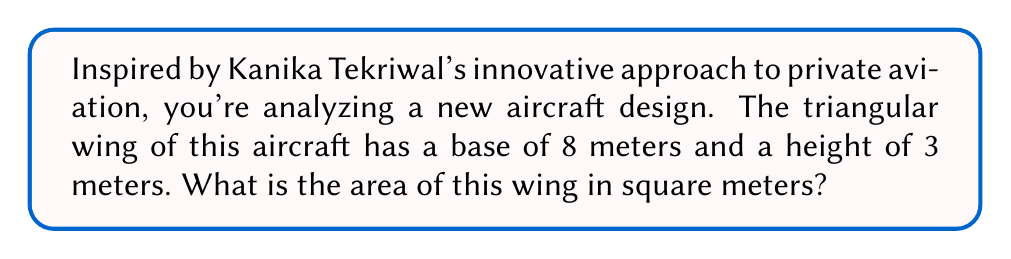Show me your answer to this math problem. To find the area of a triangular wing, we can use the formula for the area of a triangle:

$$A = \frac{1}{2} \times b \times h$$

Where:
$A$ = Area of the triangle
$b$ = Base of the triangle
$h$ = Height (perpendicular to the base) of the triangle

Given:
Base $(b) = 8$ meters
Height $(h) = 3$ meters

Let's substitute these values into the formula:

$$A = \frac{1}{2} \times 8 \times 3$$

Simplifying:
$$A = 4 \times 3 = 12$$

Therefore, the area of the triangular aircraft wing is 12 square meters.

[asy]
import geometry;

size(200);
pair A = (0,0), B = (8,0), C = (4,3);
draw(A--B--C--cycle);
draw(C--(4,0), dashed);
label("8 m", (4,0), S);
label("3 m", (4,1.5), E);
label("A = 12 m²", (4,1), fontsize(10));
[/asy]
Answer: 12 m² 